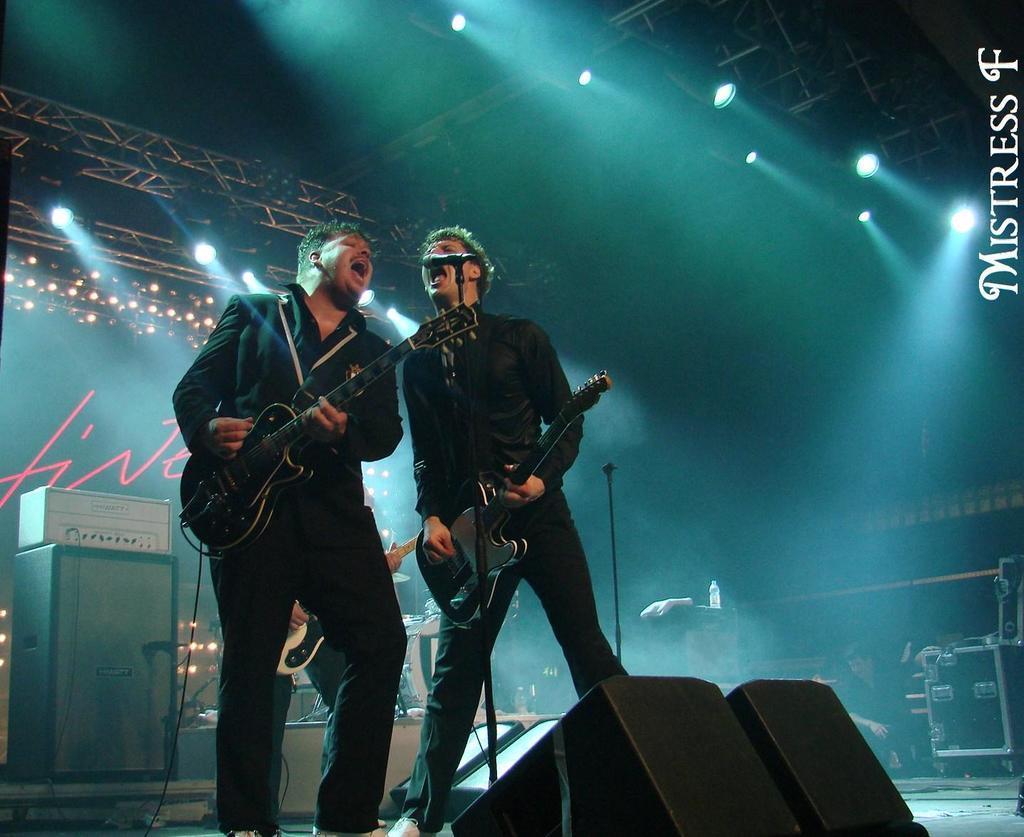Can you describe this image briefly? In the center of the image there are two people standing and holding guitars in their hands. We can see a mic placed before them. At the bottom there are speakers. In the background there is an instrument, band, lights and rods. 